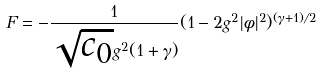<formula> <loc_0><loc_0><loc_500><loc_500>F = - \frac { 1 } { \sqrt { c _ { 0 } } g ^ { 2 } ( 1 + \gamma ) } ( 1 - 2 g ^ { 2 } | \phi | ^ { 2 } ) ^ { ( \gamma + 1 ) / 2 }</formula> 